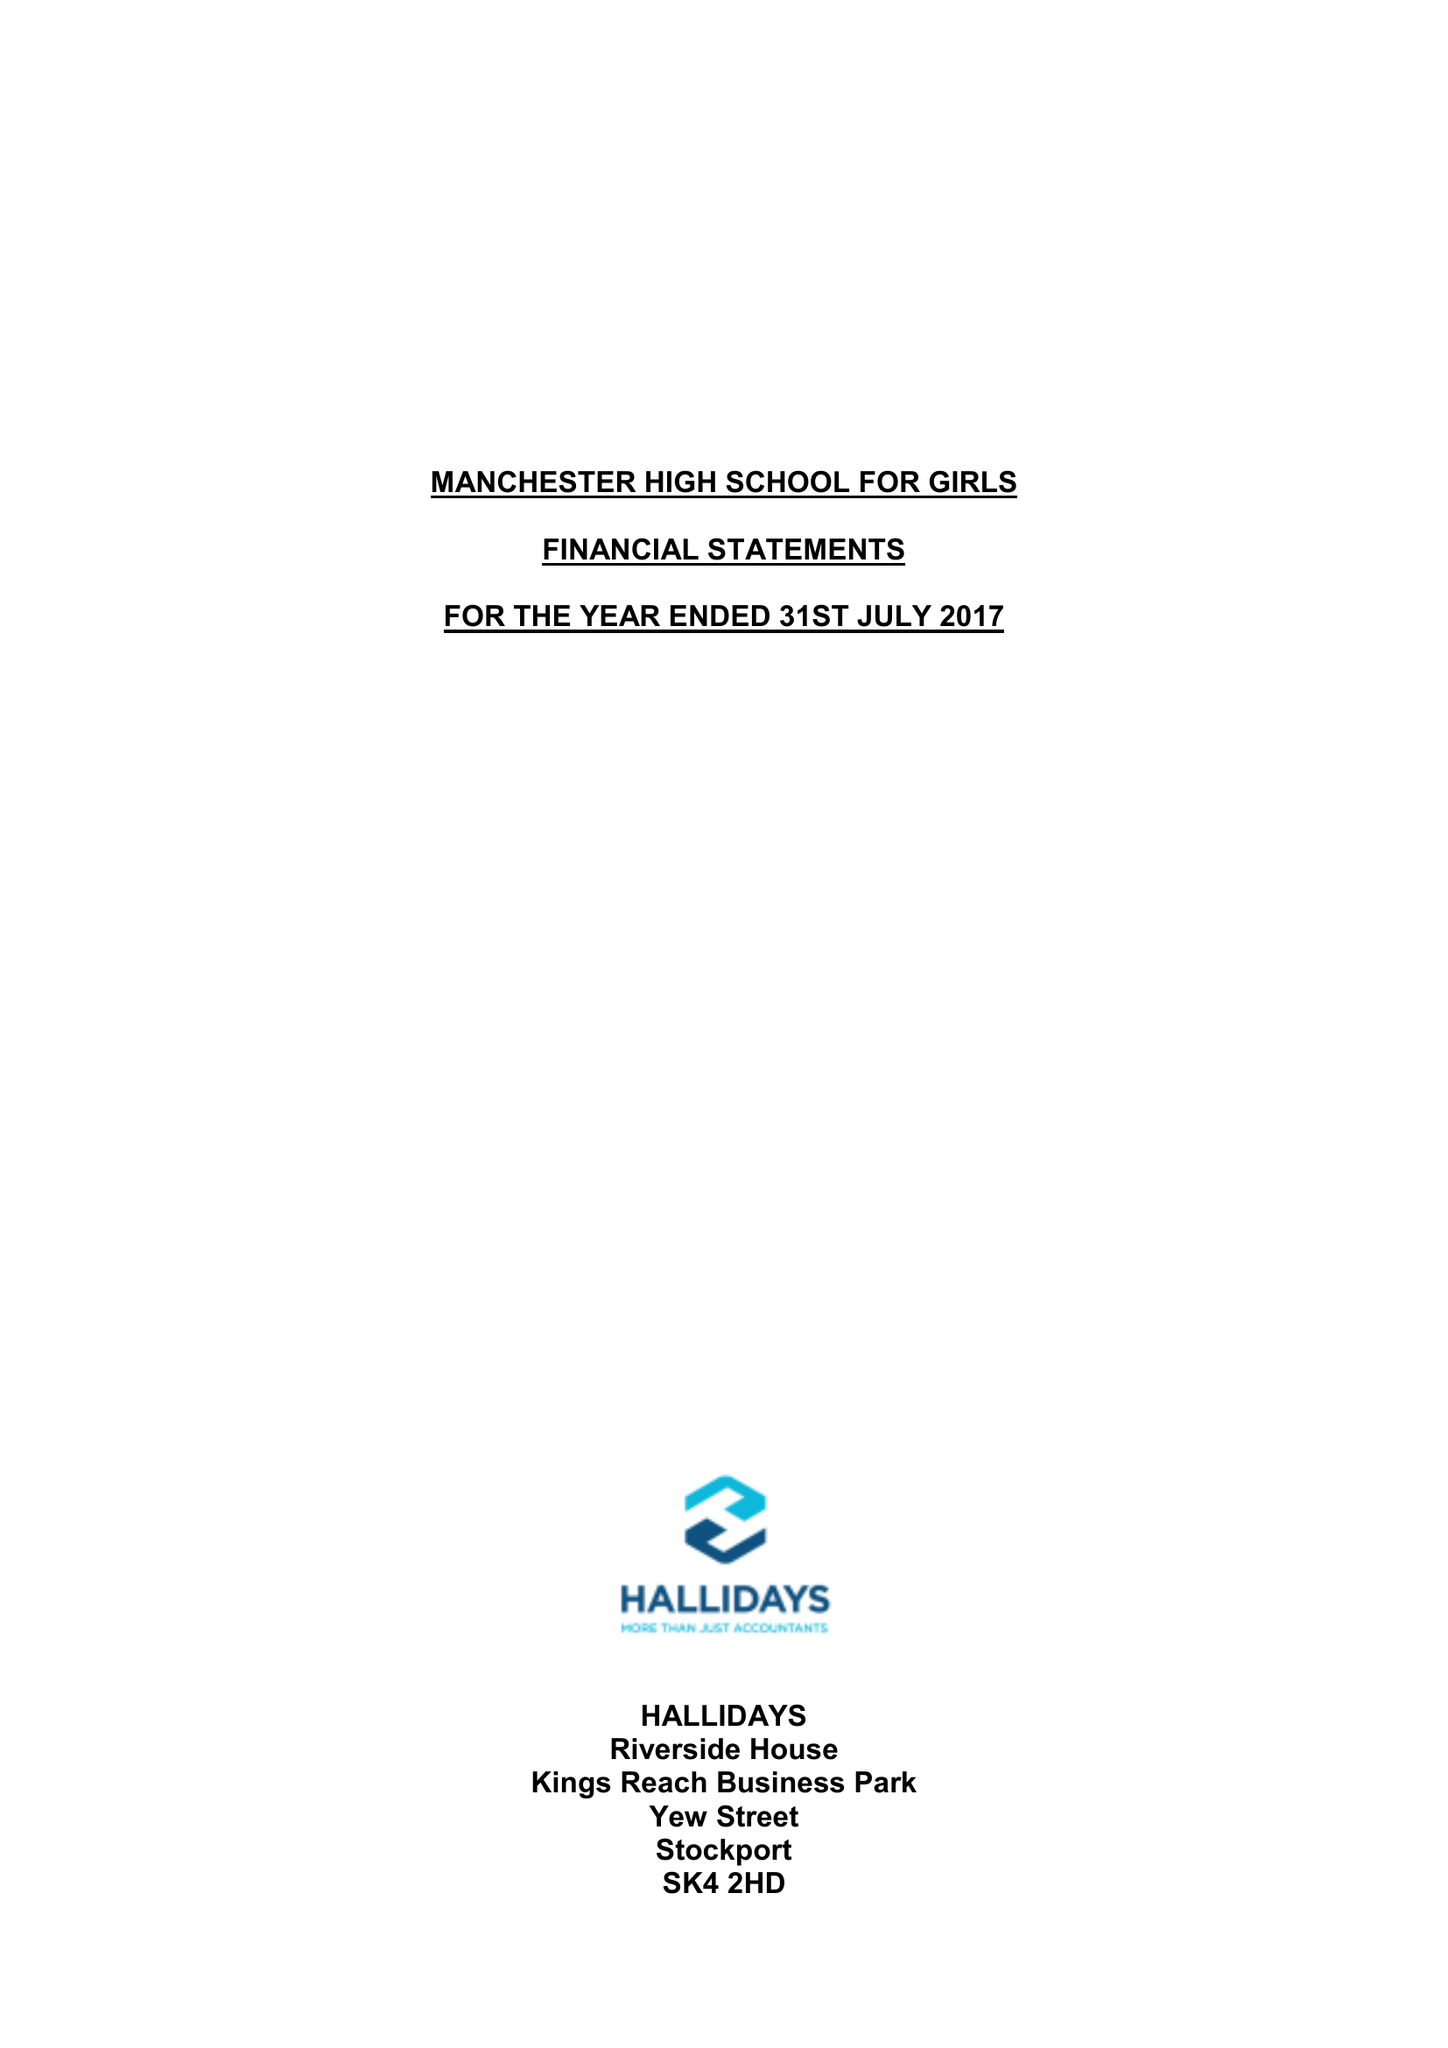What is the value for the income_annually_in_british_pounds?
Answer the question using a single word or phrase. 10346395.00 